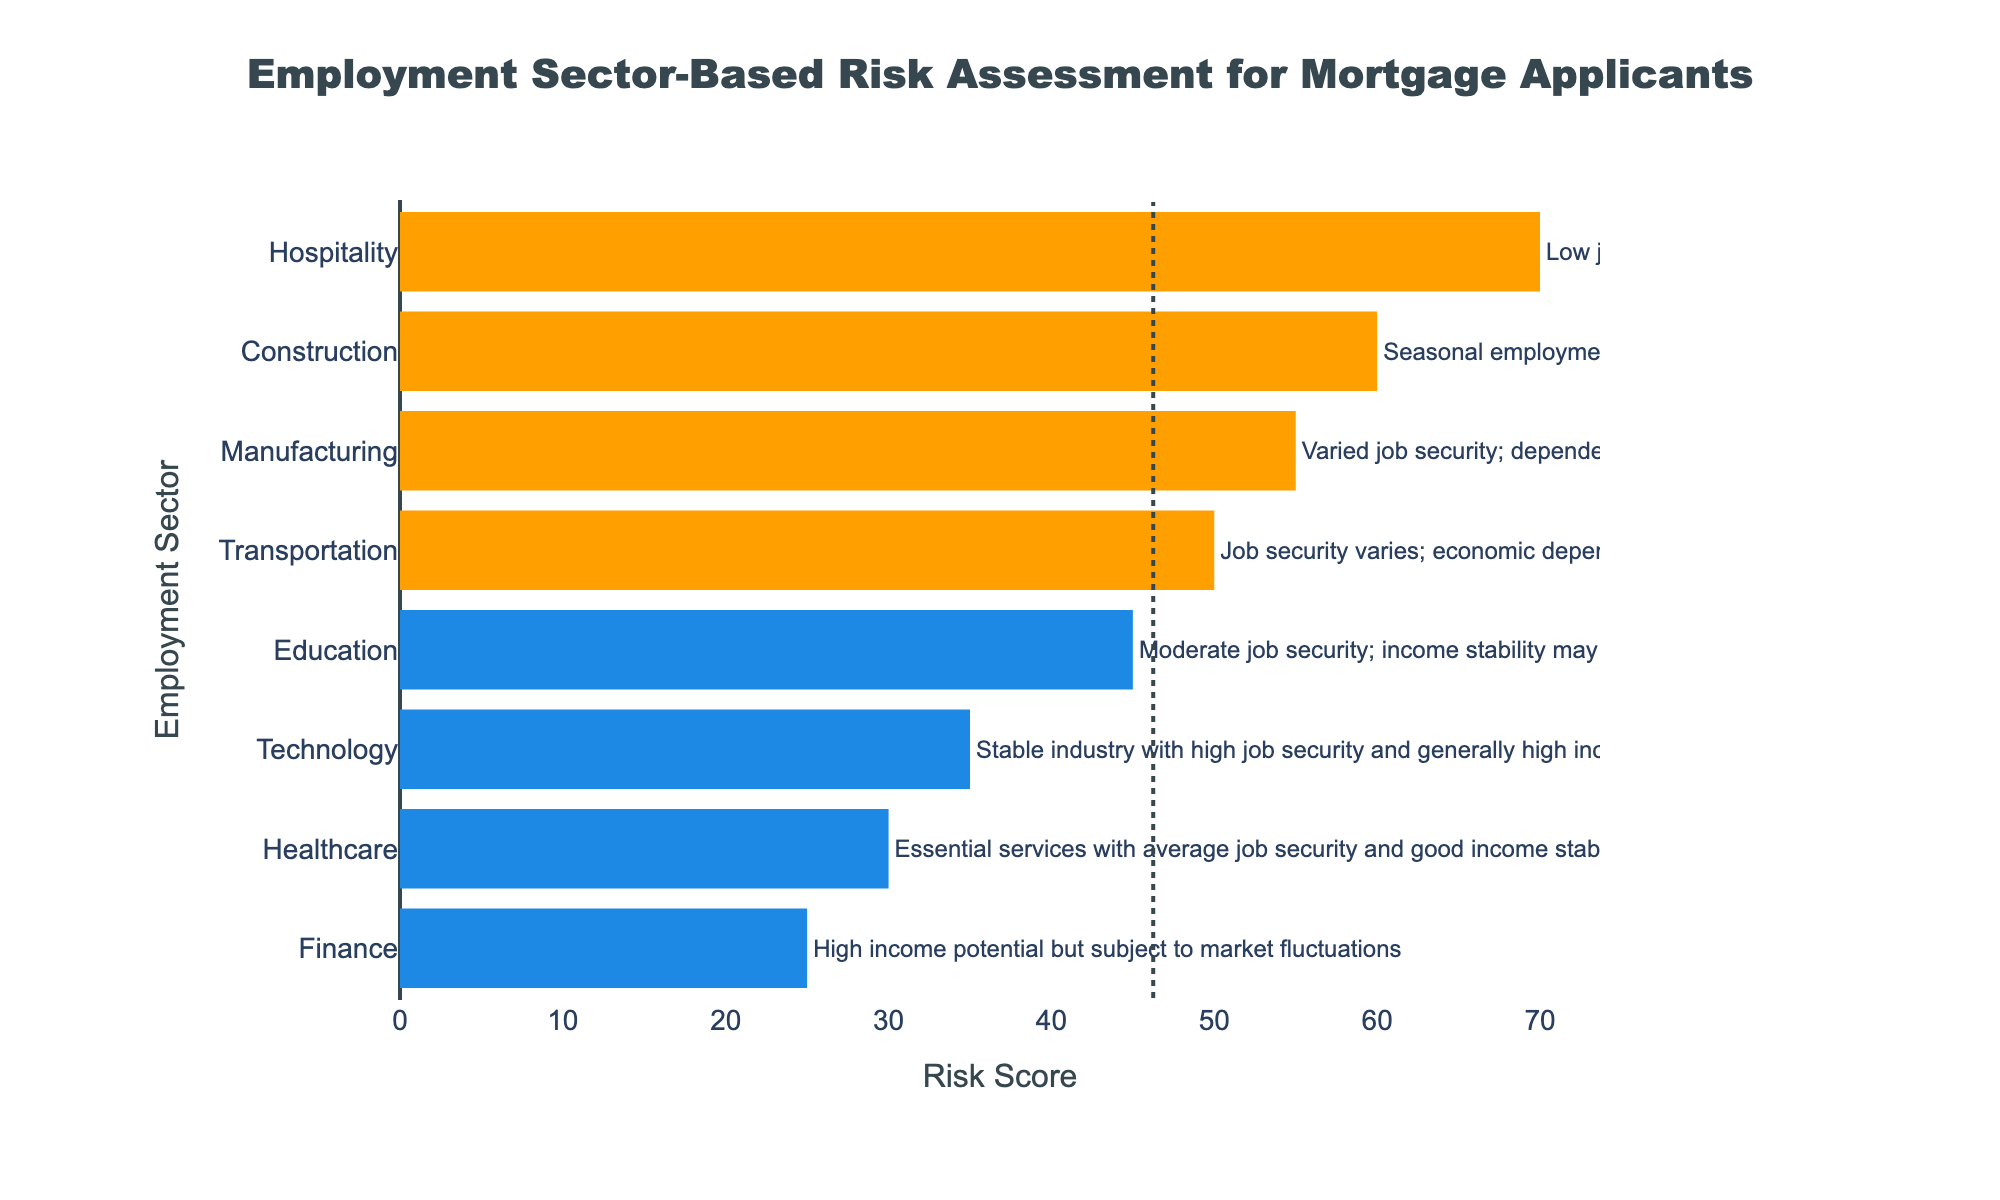What is the risk score for the Finance sector? Look at the bar labeled "Finance" and read the value corresponding to its length.
Answer: 25 Which employment sector has the highest risk score? Identify the longest bar in the graph. The longest bar corresponds to the Hospitality sector.
Answer: Hospitality Compare the risk scores of Technology and Healthcare sectors. Which one has a higher risk score? Look at the bars for Technology and Healthcare. The Technology sector has a risk score of 35, whereas the Healthcare sector has a risk score of 30. So, Technology has a higher risk score.
Answer: Technology What is the midpoint risk score used in the chart? Identify the dotted vertical line on the graph, which represents the midpoint. This line crosses the x-axis at the midpoint risk score value.
Answer: 46.25 How many sectors have risk scores below the midpoint? Count the number of bars that are colored blue, indicating risk scores below the midpoint.
Answer: 4 Calculate the average risk score for the Manufacturing, Construction, and Hospitality sectors. Sum the risk scores for these sectors and divide by the number of sectors: \((55 + 60 + 70) / 3 = 185 / 3 = 61.67\).
Answer: 61.67 Which sector has the lowest risk score, and what is that score? Identify the shortest bar. The shortest bar corresponds to the Finance sector with a risk score of 25.
Answer: Finance, 25 Compare the risk scores for the Education and Transportation sectors. Which one is lower, and by how much? The Education sector has a risk score of 45, and the Transportation sector has a risk score of 50. The difference is \(50 - 45 = 5\).
Answer: Education, 5 What color represents sectors with risk scores above the midpoint? Identify the color of the bars that signify sectors with risk scores above the midpoint. These bars are colored orange.
Answer: Orange Find the median risk score among all the employment sectors. Arrange the risk scores in ascending order and find the middle value. The risk scores are: 25, 30, 35, 45, 50, 55, 60, 70. The middle values are 45 and 50, and the median is \((45 + 50) / 2 = 47.5\).
Answer: 47.5 